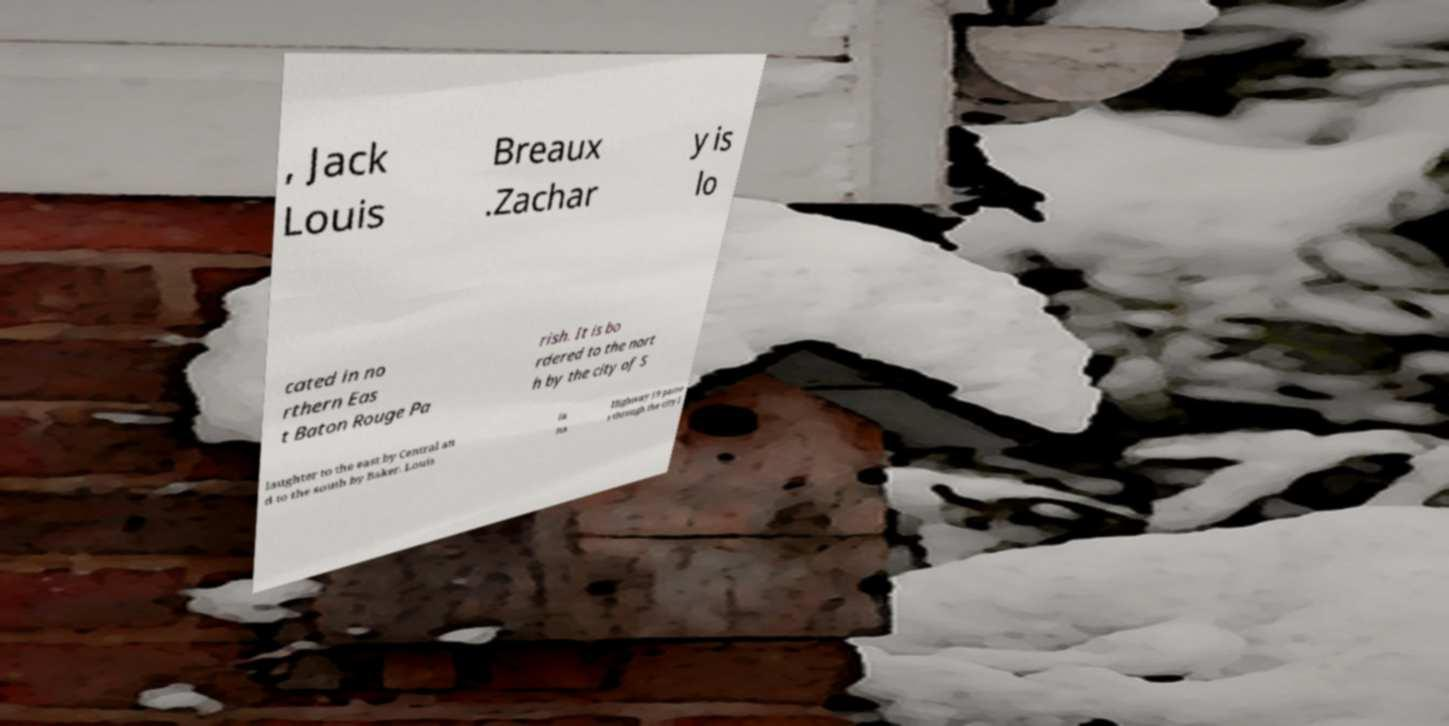Can you read and provide the text displayed in the image?This photo seems to have some interesting text. Can you extract and type it out for me? , Jack Louis Breaux .Zachar y is lo cated in no rthern Eas t Baton Rouge Pa rish. It is bo rdered to the nort h by the city of S laughter to the east by Central an d to the south by Baker. Louis ia na Highway 19 passe s through the city l 